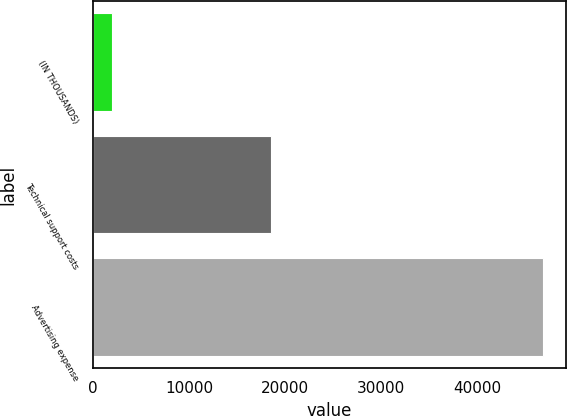Convert chart. <chart><loc_0><loc_0><loc_500><loc_500><bar_chart><fcel>(IN THOUSANDS)<fcel>Technical support costs<fcel>Advertising expense<nl><fcel>2001<fcel>18502<fcel>46884<nl></chart> 